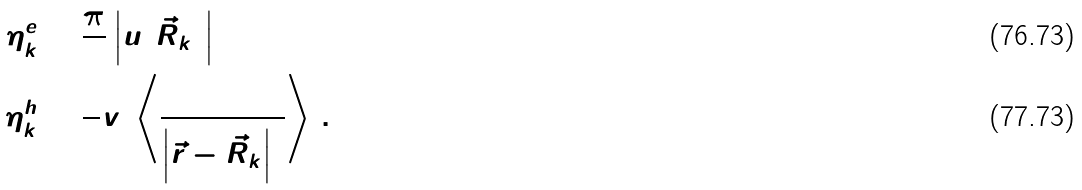<formula> <loc_0><loc_0><loc_500><loc_500>\eta ^ { e } _ { k } & = \frac { \pi } { 3 } \left | u ( \vec { R } _ { k } ) \right | ^ { 2 } \\ \eta ^ { h } _ { k } & = \frac { 8 } { 5 } v _ { 0 } \left \langle \frac { 1 } { \left | \vec { r } - \vec { R } _ { k } \right | ^ { 3 } } \right \rangle \, .</formula> 